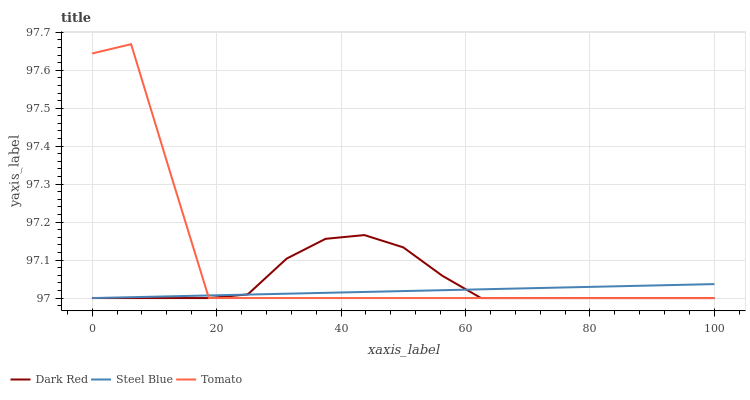Does Dark Red have the minimum area under the curve?
Answer yes or no. No. Does Dark Red have the maximum area under the curve?
Answer yes or no. No. Is Dark Red the smoothest?
Answer yes or no. No. Is Dark Red the roughest?
Answer yes or no. No. Does Dark Red have the highest value?
Answer yes or no. No. 